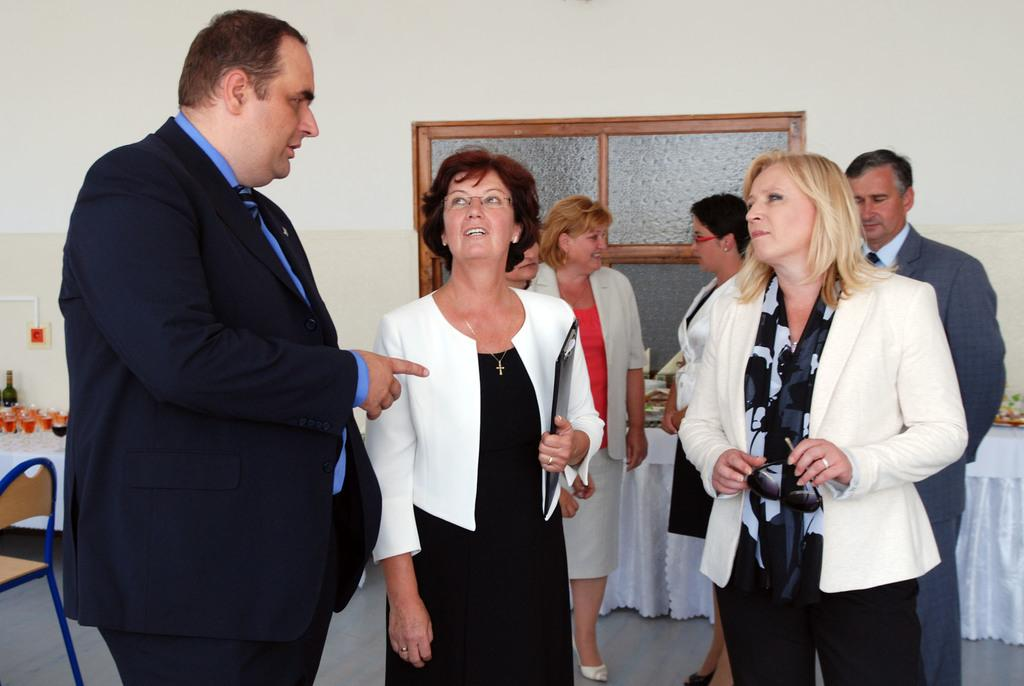What are the people in the image doing? There are persons standing in the image, but their specific actions are not clear. What object is located on the left side of the image? There is a chair on the left side of the image. What type of container is visible in the image? There is a bottle in the image. What type of tableware is present in the image? There are glasses in the image. What can be seen in the background of the image? There is a window visible in the background of the image. What type of government is depicted in the image? There is no depiction of a government in the image; it features persons standing, a chair, a bottle, glasses, and a window. How many fingers are visible on the persons in the image? The number of fingers visible on the persons in the image cannot be determined from the provided facts. 